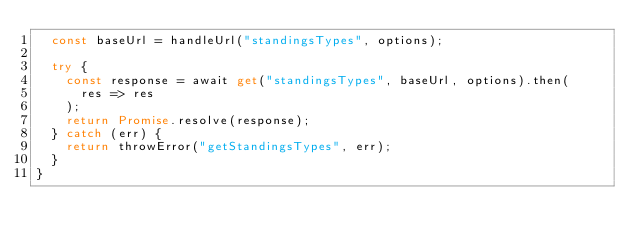<code> <loc_0><loc_0><loc_500><loc_500><_TypeScript_>  const baseUrl = handleUrl("standingsTypes", options);

  try {
    const response = await get("standingsTypes", baseUrl, options).then(
      res => res
    );
    return Promise.resolve(response);
  } catch (err) {
    return throwError("getStandingsTypes", err);
  }
}
</code> 